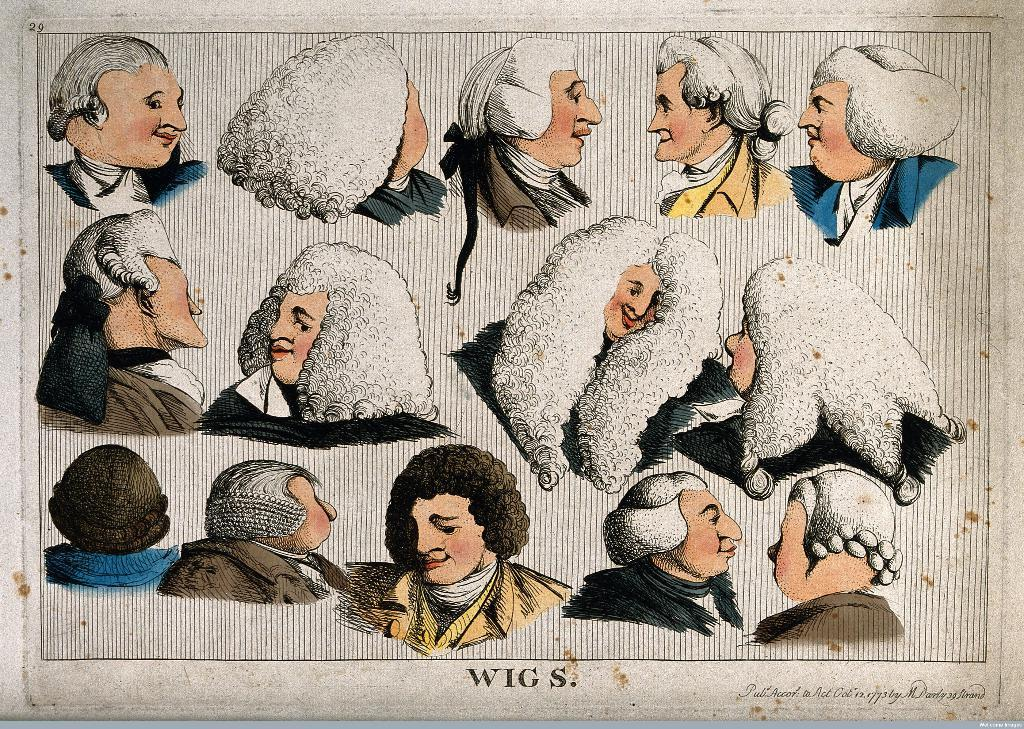What is present on the poster in the image? The poster contains images and text. Can you describe the images on the poster? Unfortunately, the specific images on the poster cannot be described without more information. What type of information is conveyed through the text on the poster? The content of the text on the poster cannot be determined without more information. What color is the kite that the grandmother is holding in the image? There is no kite or grandmother present in the image; it only contains a poster with images and text. 